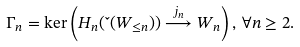Convert formula to latex. <formula><loc_0><loc_0><loc_500><loc_500>\Gamma _ { n } = \ker \left ( H _ { n } ( \L ( W _ { \leq n } ) ) \overset { j _ { n } } { \longrightarrow } W _ { n } \right ) , \, \forall n \geq 2 .</formula> 